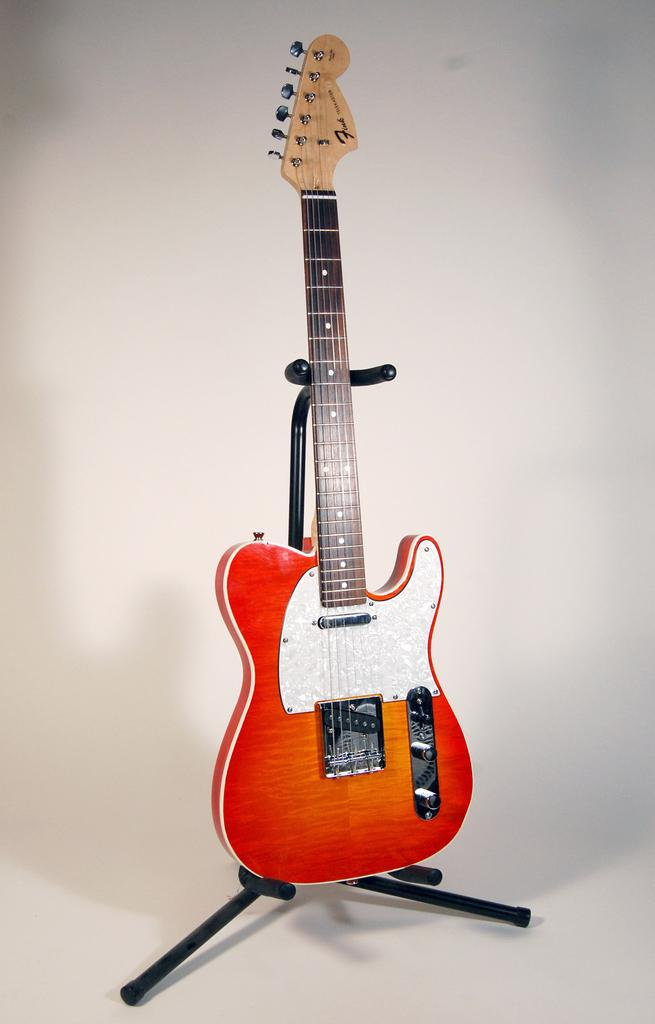What musical instrument is present in the image? There is a guitar on a stand in the image. How is the guitar positioned in the image? The guitar is on a stand in the image. What type of tray is being used to hold the guitar in the image? There is no tray present in the image; the guitar is on a stand. How does the guitar interact with the person's toe in the image? There is no person or toe present in the image; it only features a guitar on a stand. 